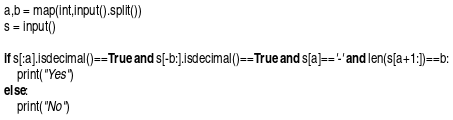Convert code to text. <code><loc_0><loc_0><loc_500><loc_500><_Python_>a,b = map(int,input().split())
s = input()

if s[:a].isdecimal()==True and s[-b:].isdecimal()==True and s[a]=='-' and len(s[a+1:])==b:
    print("Yes")
else:
    print("No")
</code> 